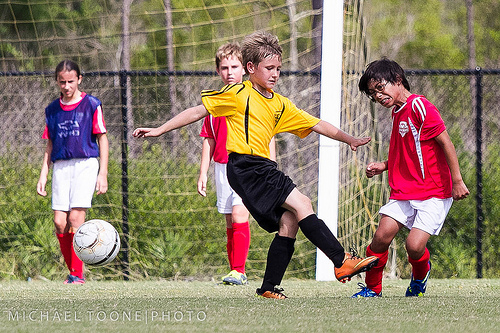<image>
Is there a girl in front of the ball? No. The girl is not in front of the ball. The spatial positioning shows a different relationship between these objects. 